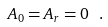Convert formula to latex. <formula><loc_0><loc_0><loc_500><loc_500>A _ { 0 } = A _ { r } = 0 \ .</formula> 